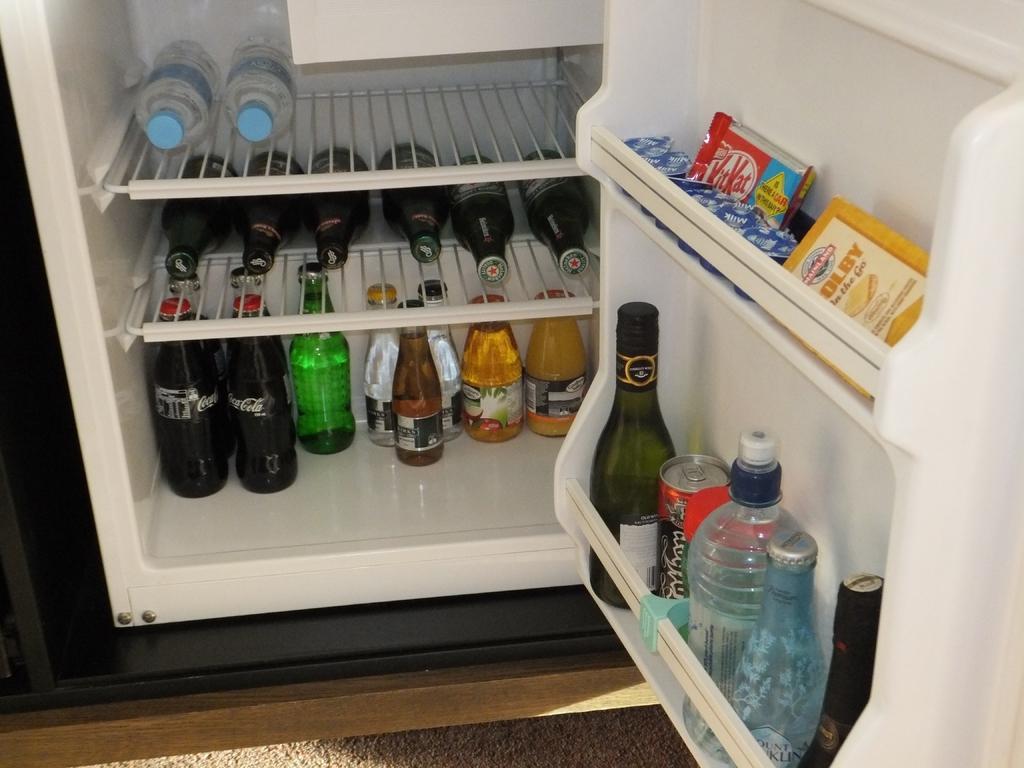Can you describe this image briefly? The images taken from inside a fridge, there are two bottles, some alcohol bottles, some aerated beverages,chocolates and cheese in the fridge, the fridge is of white color. 